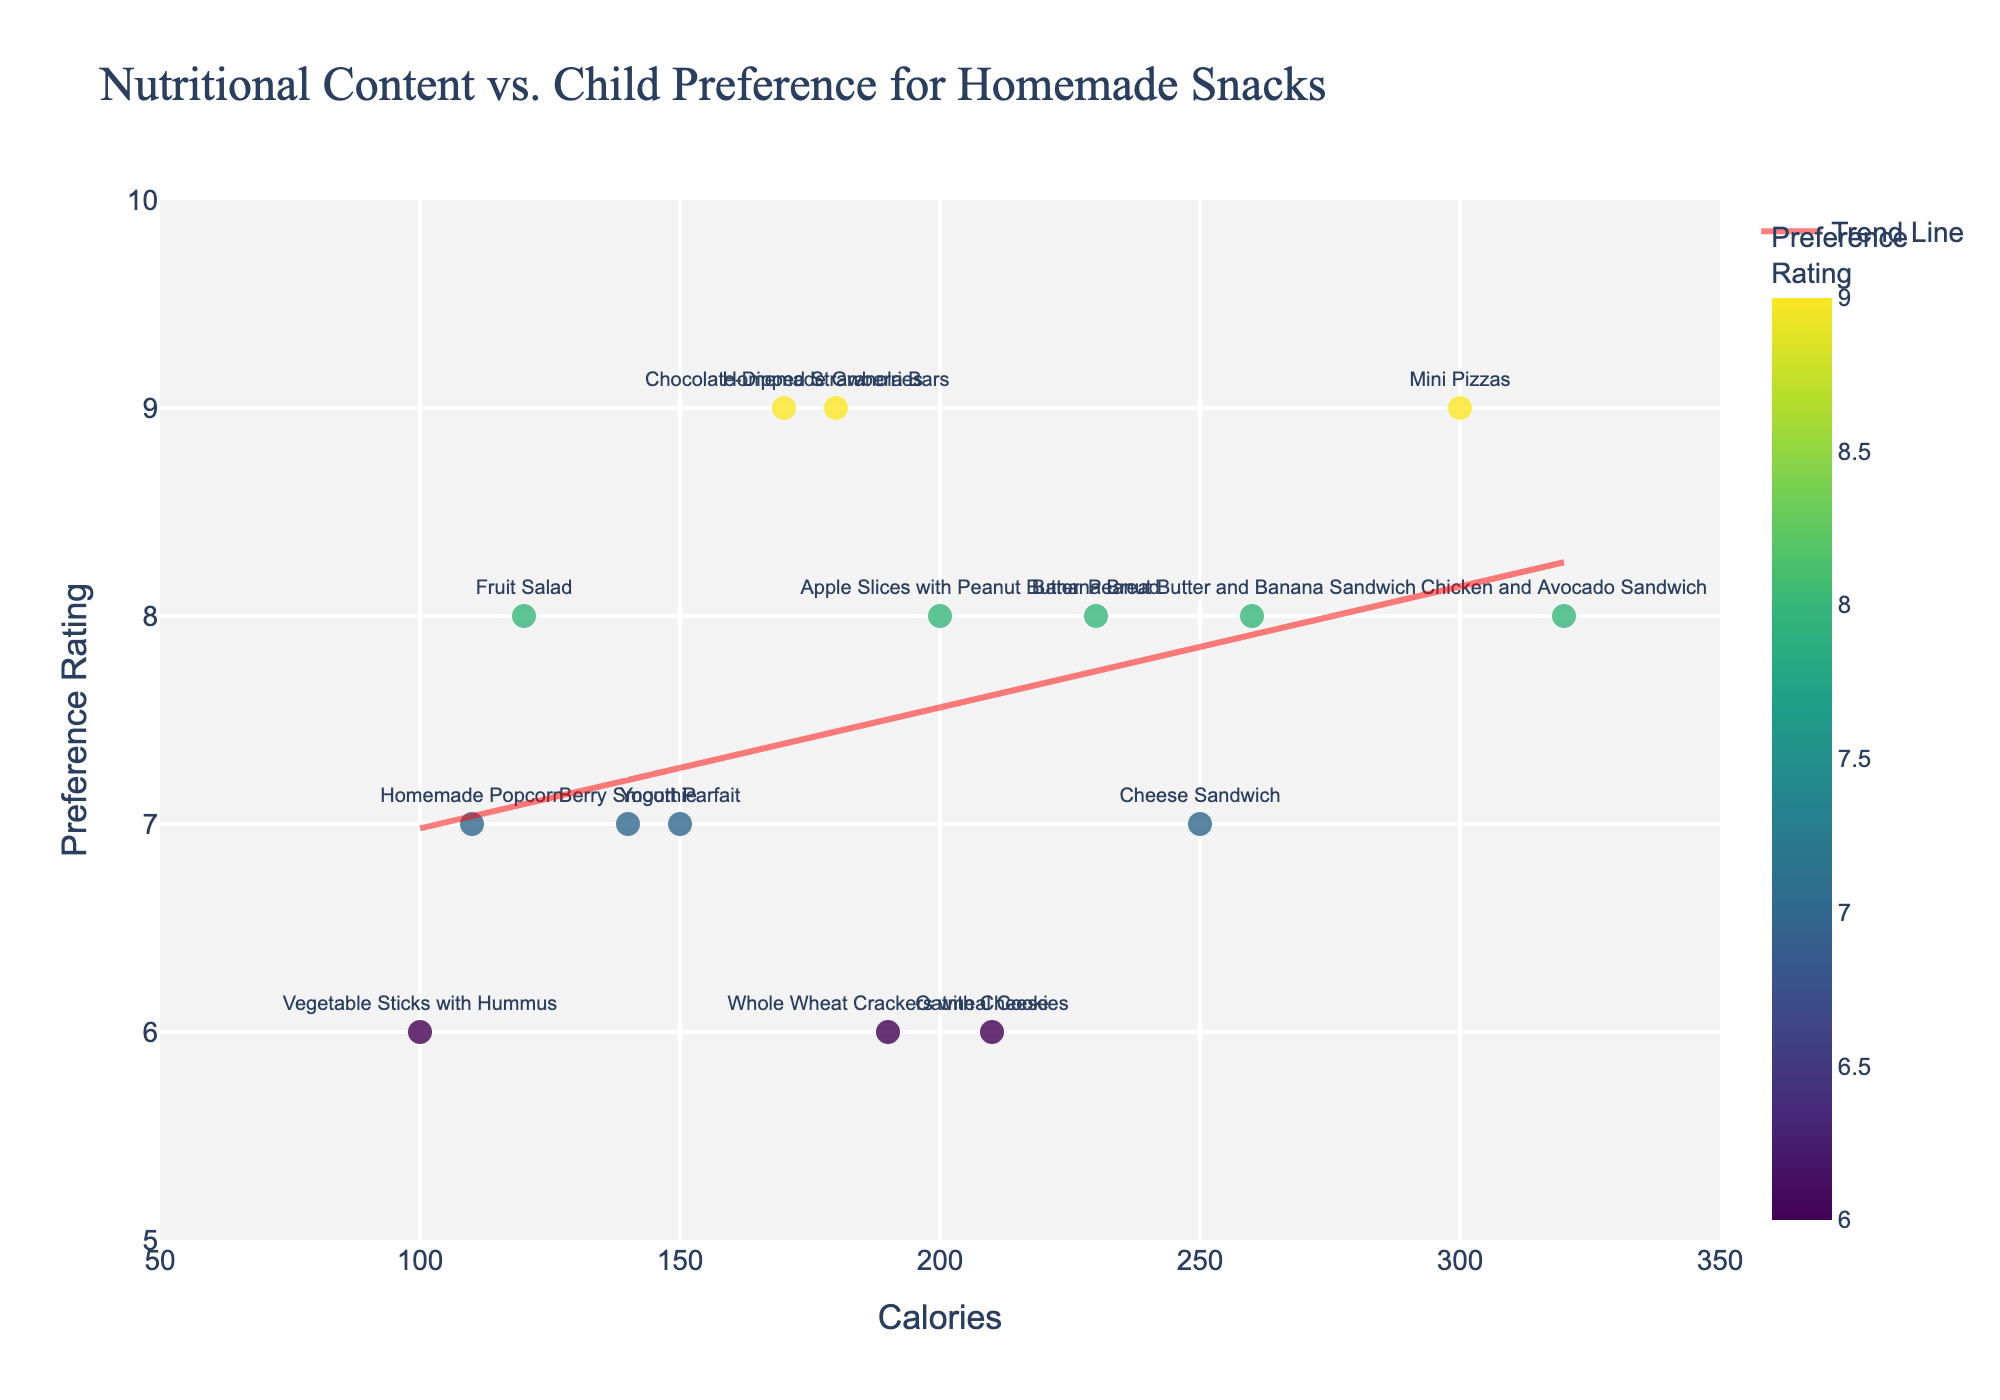How many snacks are shown in the plot? Count each distinct data point that represents a snack on the scatter plot.
Answer: 15 What is the title of the plot? Look at the text at the top of the figure.
Answer: Nutritional Content vs. Child Preference for Homemade Snacks Which snack has the highest child preference rating? Locate the highest value on the y-axis (Preference Rating) and check the corresponding data point's label.
Answer: Mini Pizzas, Homemade Granola Bars, Chocolate-Dipped Strawberries What is the child preference rating for the snack with the lowest calories? Find the data point with the lowest x-axis value (Calories) and check its corresponding y-axis value (Preference Rating).
Answer: 6 How many snacks have a child preference rating of 8? Count the data points that align with the y-axis value of 8.
Answer: 5 Is there a general trend between nutritional content and child preference rating? Observe the direction of the trend line added to the scatter plot. Determine whether it slopes upwards or downwards.
Answer: Downward trend Which snack has more calories: Chicken and Avocado Sandwich or Banana Bread? Look at the x-axis (Calories) values for both Chicken and Avocado Sandwich and Banana Bread, then compare them.
Answer: Chicken and Avocado Sandwich What is the difference in calories between the snack with the highest preference rating and the one with the lowest preference rating? Identify and subtract the x-axis (Calories) values of the data points with the highest and lowest y-axis (Preference Rating) values.
Answer: 230 (Mini Pizzas - Vegetable Sticks with Hummus) For the snack with 200 calories, what is its child preference rating? Locate the data point on the x-axis at 200 calories and check its corresponding y-axis (Preference Rating) value.
Answer: 8 